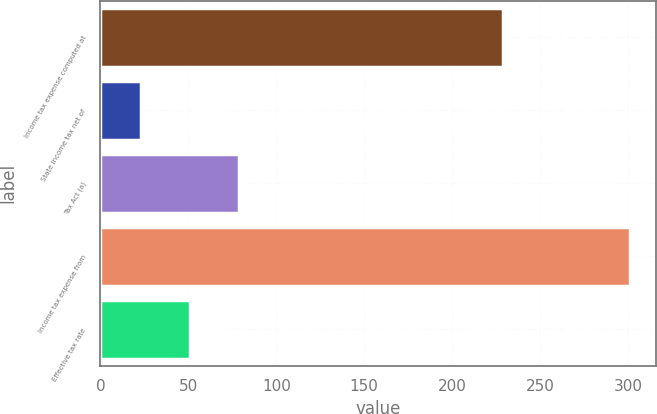Convert chart to OTSL. <chart><loc_0><loc_0><loc_500><loc_500><bar_chart><fcel>Income tax expense computed at<fcel>State income tax net of<fcel>Tax Act (a)<fcel>Income tax expense from<fcel>Effective tax rate<nl><fcel>229<fcel>23<fcel>78.6<fcel>301<fcel>50.8<nl></chart> 